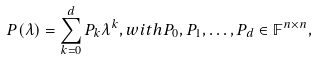<formula> <loc_0><loc_0><loc_500><loc_500>P ( \lambda ) = \sum _ { k = 0 } ^ { d } P _ { k } \lambda ^ { k } , w i t h P _ { 0 } , P _ { 1 } , \hdots , P _ { d } \in \mathbb { F } ^ { n \times n } ,</formula> 